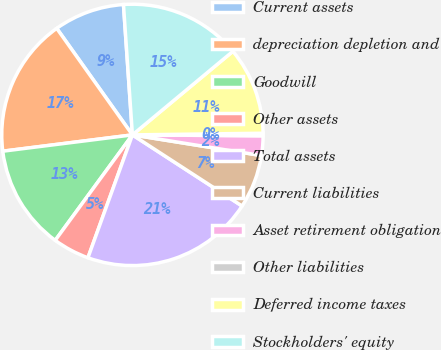<chart> <loc_0><loc_0><loc_500><loc_500><pie_chart><fcel>Current assets<fcel>depreciation depletion and<fcel>Goodwill<fcel>Other assets<fcel>Total assets<fcel>Current liabilities<fcel>Asset retirement obligation<fcel>Other liabilities<fcel>Deferred income taxes<fcel>Stockholders' equity<nl><fcel>8.74%<fcel>17.16%<fcel>12.95%<fcel>4.53%<fcel>21.37%<fcel>6.63%<fcel>2.42%<fcel>0.31%<fcel>10.84%<fcel>15.05%<nl></chart> 